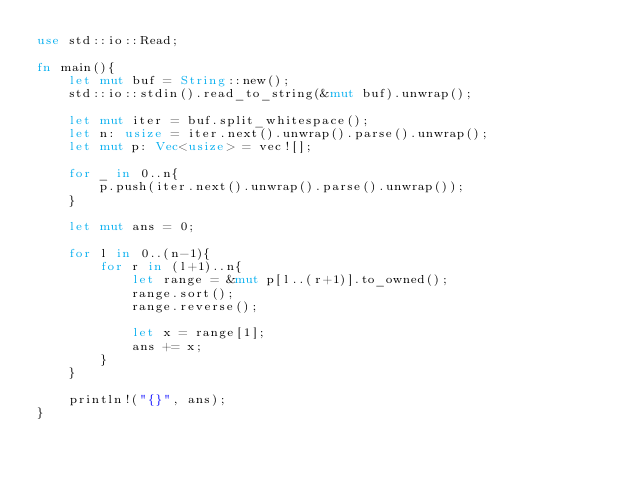Convert code to text. <code><loc_0><loc_0><loc_500><loc_500><_Rust_>use std::io::Read;

fn main(){
    let mut buf = String::new();
    std::io::stdin().read_to_string(&mut buf).unwrap();

    let mut iter = buf.split_whitespace();
    let n: usize = iter.next().unwrap().parse().unwrap();
    let mut p: Vec<usize> = vec![];

    for _ in 0..n{
        p.push(iter.next().unwrap().parse().unwrap());
    }

    let mut ans = 0;

    for l in 0..(n-1){
        for r in (l+1)..n{
            let range = &mut p[l..(r+1)].to_owned();
            range.sort();
            range.reverse();

            let x = range[1];
            ans += x;
        }
    }

    println!("{}", ans);
}
</code> 